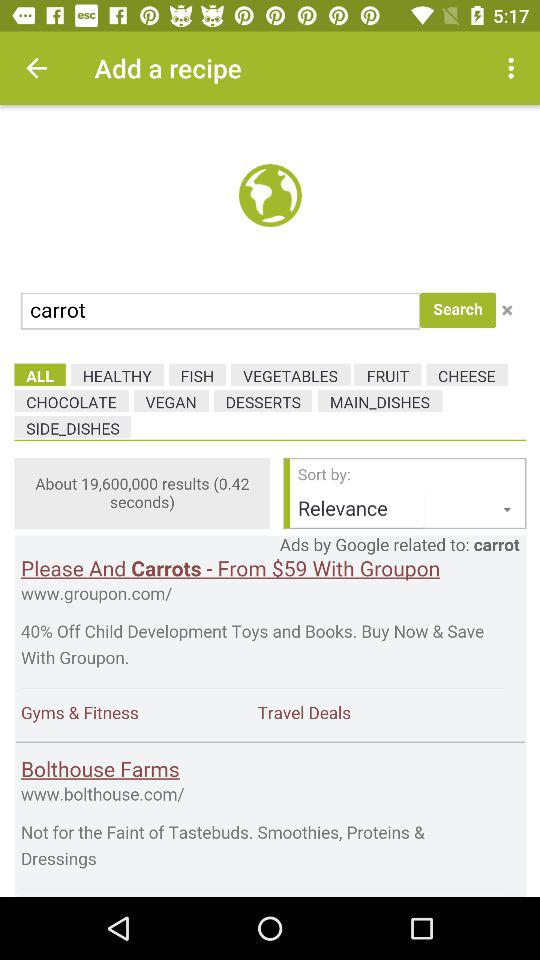How many results are there for the search term 'carrot'?
Answer the question using a single word or phrase. 19,600,000 